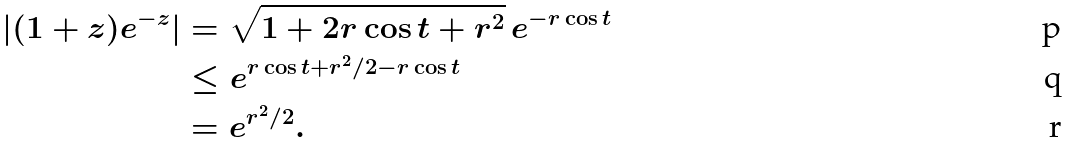<formula> <loc_0><loc_0><loc_500><loc_500>| ( 1 + z ) e ^ { - z } | & = \sqrt { 1 + 2 r \cos t + r ^ { 2 } } \, e ^ { - r \cos t } \\ & \leq e ^ { r \cos t + r ^ { 2 } / 2 - r \cos t } \\ & = e ^ { r ^ { 2 } / 2 } .</formula> 